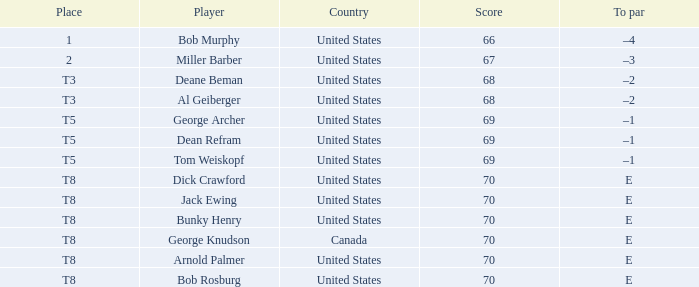When Bunky Henry placed t8, what was his To par? E. 